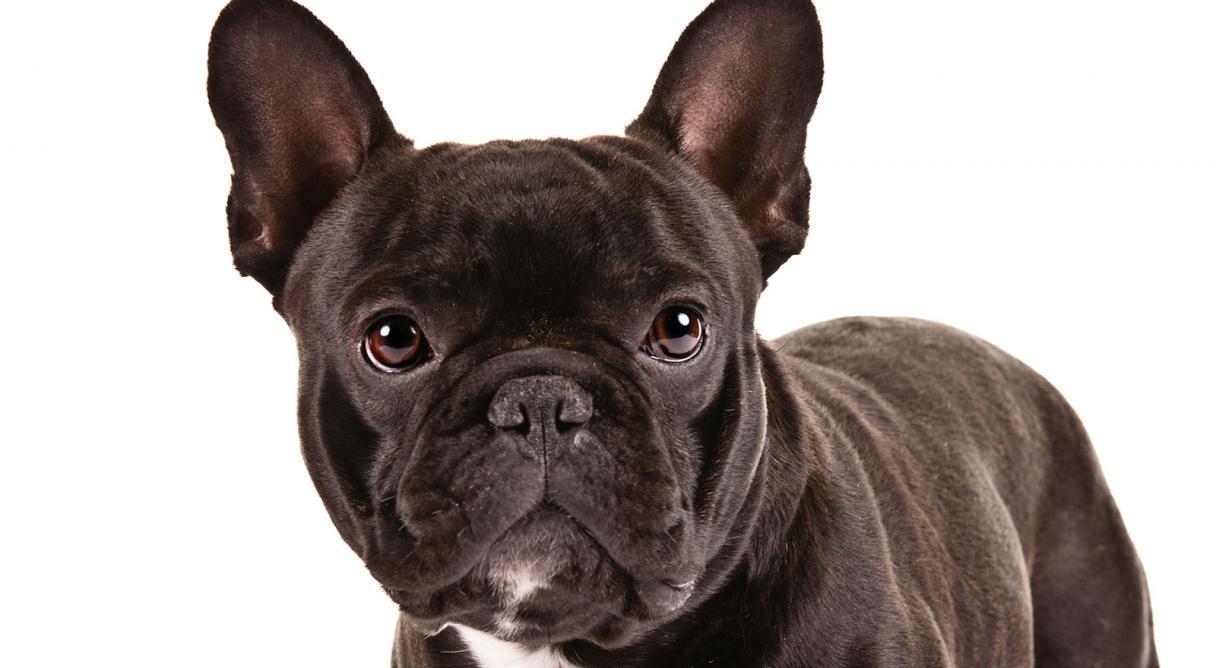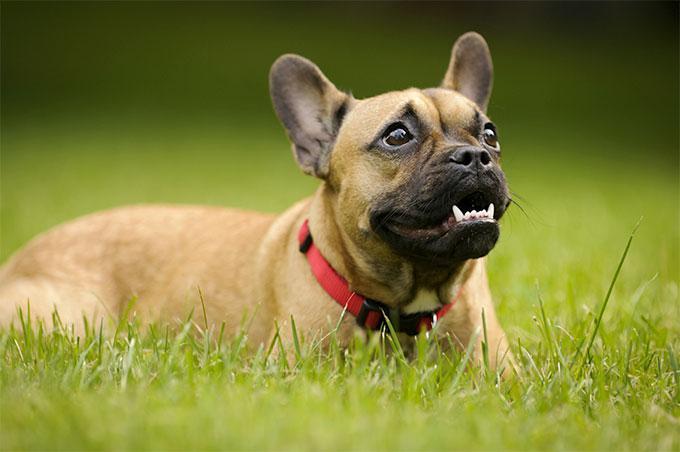The first image is the image on the left, the second image is the image on the right. For the images shown, is this caption "At least one dog is wearing a red collar." true? Answer yes or no. Yes. The first image is the image on the left, the second image is the image on the right. Considering the images on both sides, is "There is atleast one white, pied french bulldog." valid? Answer yes or no. No. 